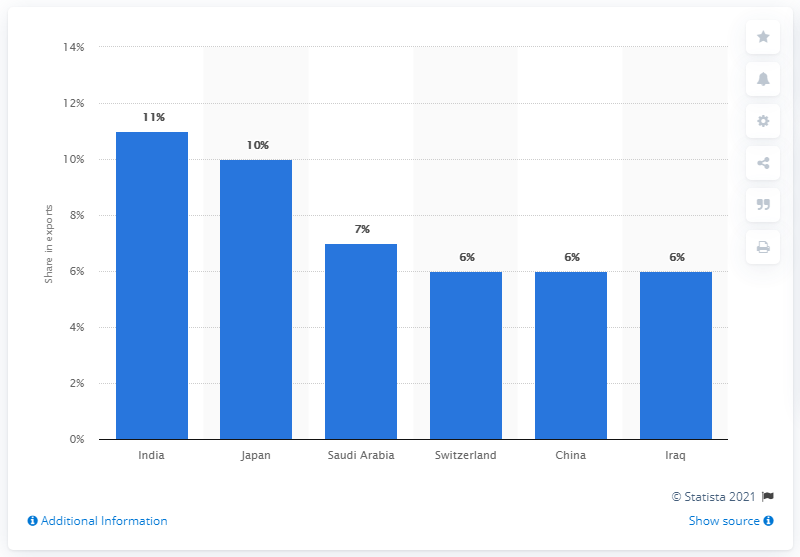Outline some significant characteristics in this image. The United Arab Emirates' main export partner in 2019 was India. 